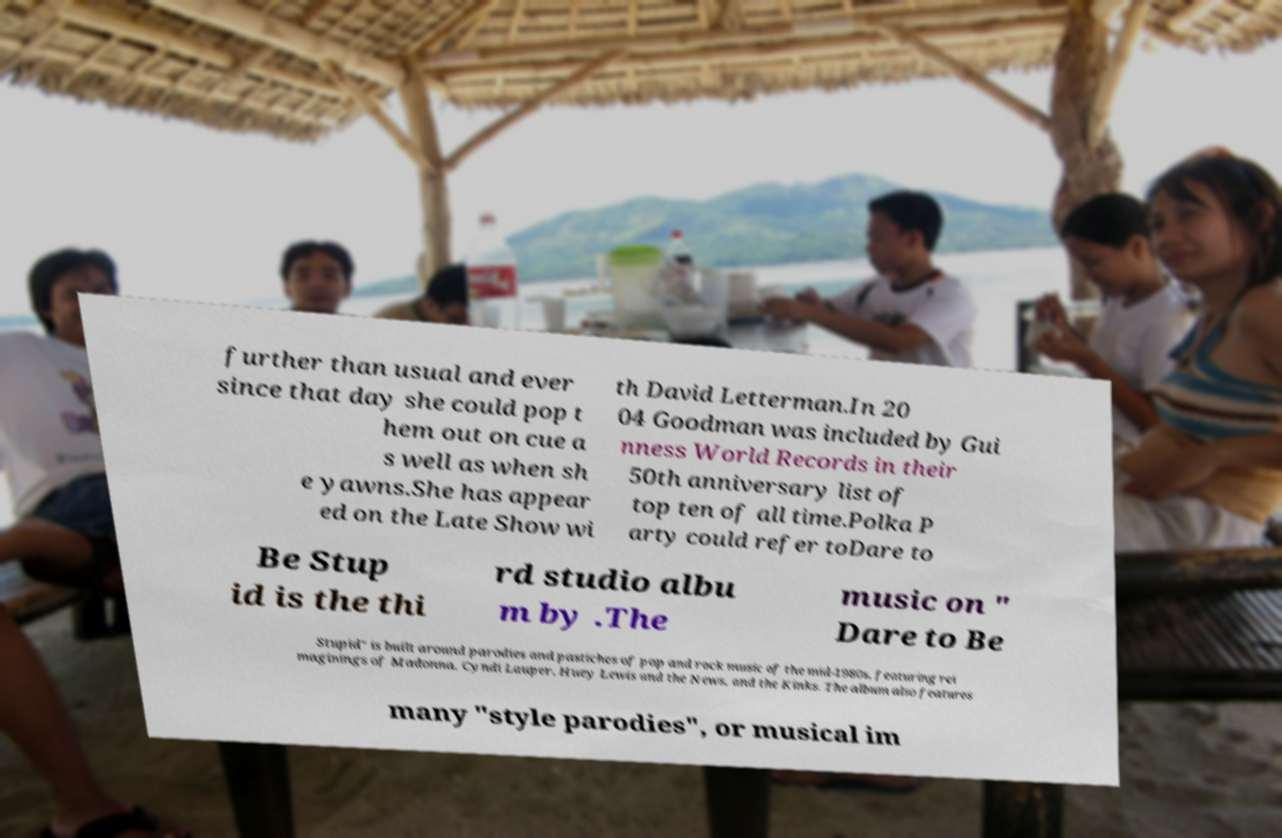For documentation purposes, I need the text within this image transcribed. Could you provide that? further than usual and ever since that day she could pop t hem out on cue a s well as when sh e yawns.She has appear ed on the Late Show wi th David Letterman.In 20 04 Goodman was included by Gui nness World Records in their 50th anniversary list of top ten of all time.Polka P arty could refer toDare to Be Stup id is the thi rd studio albu m by .The music on " Dare to Be Stupid" is built around parodies and pastiches of pop and rock music of the mid-1980s, featuring rei maginings of Madonna, Cyndi Lauper, Huey Lewis and the News, and the Kinks. The album also features many "style parodies", or musical im 